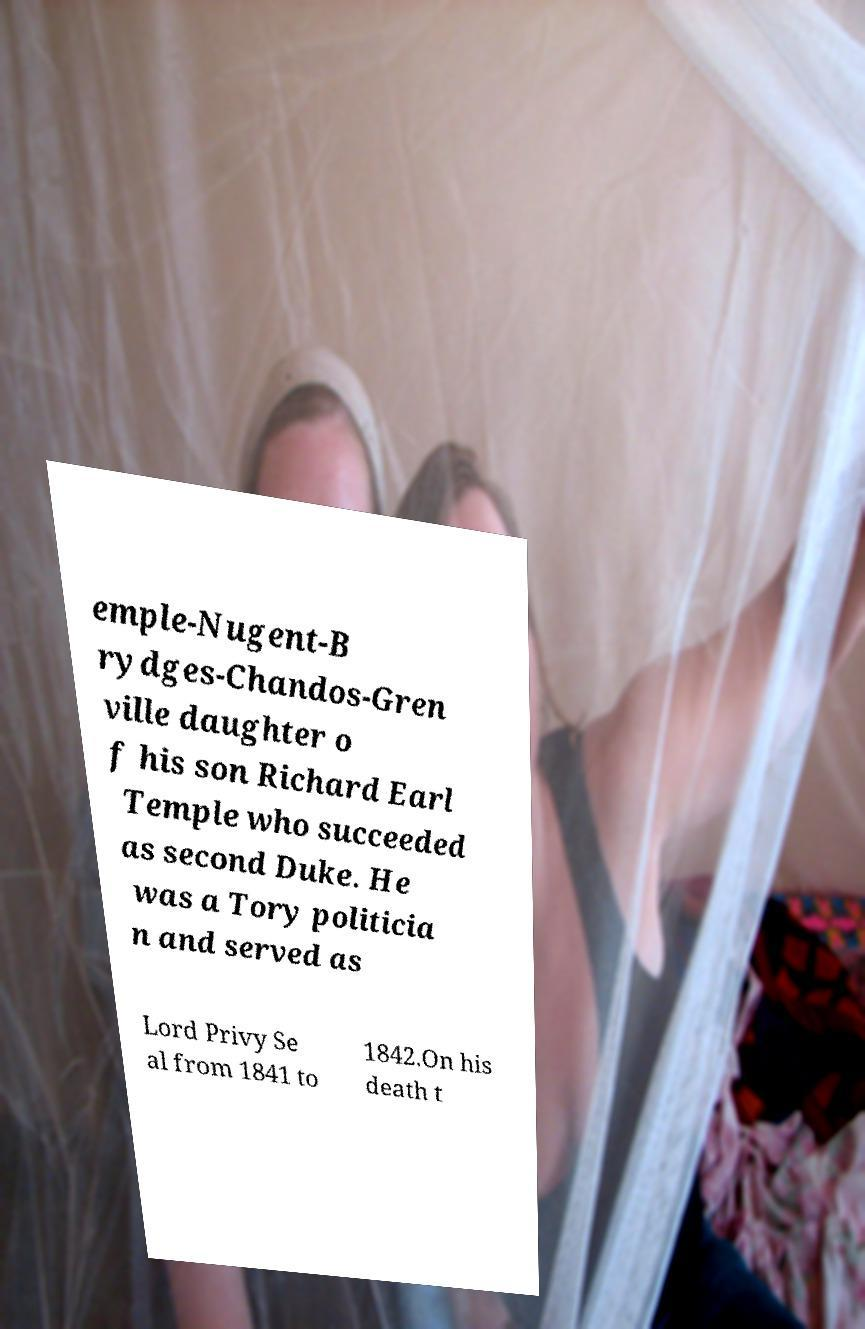Could you assist in decoding the text presented in this image and type it out clearly? emple-Nugent-B rydges-Chandos-Gren ville daughter o f his son Richard Earl Temple who succeeded as second Duke. He was a Tory politicia n and served as Lord Privy Se al from 1841 to 1842.On his death t 